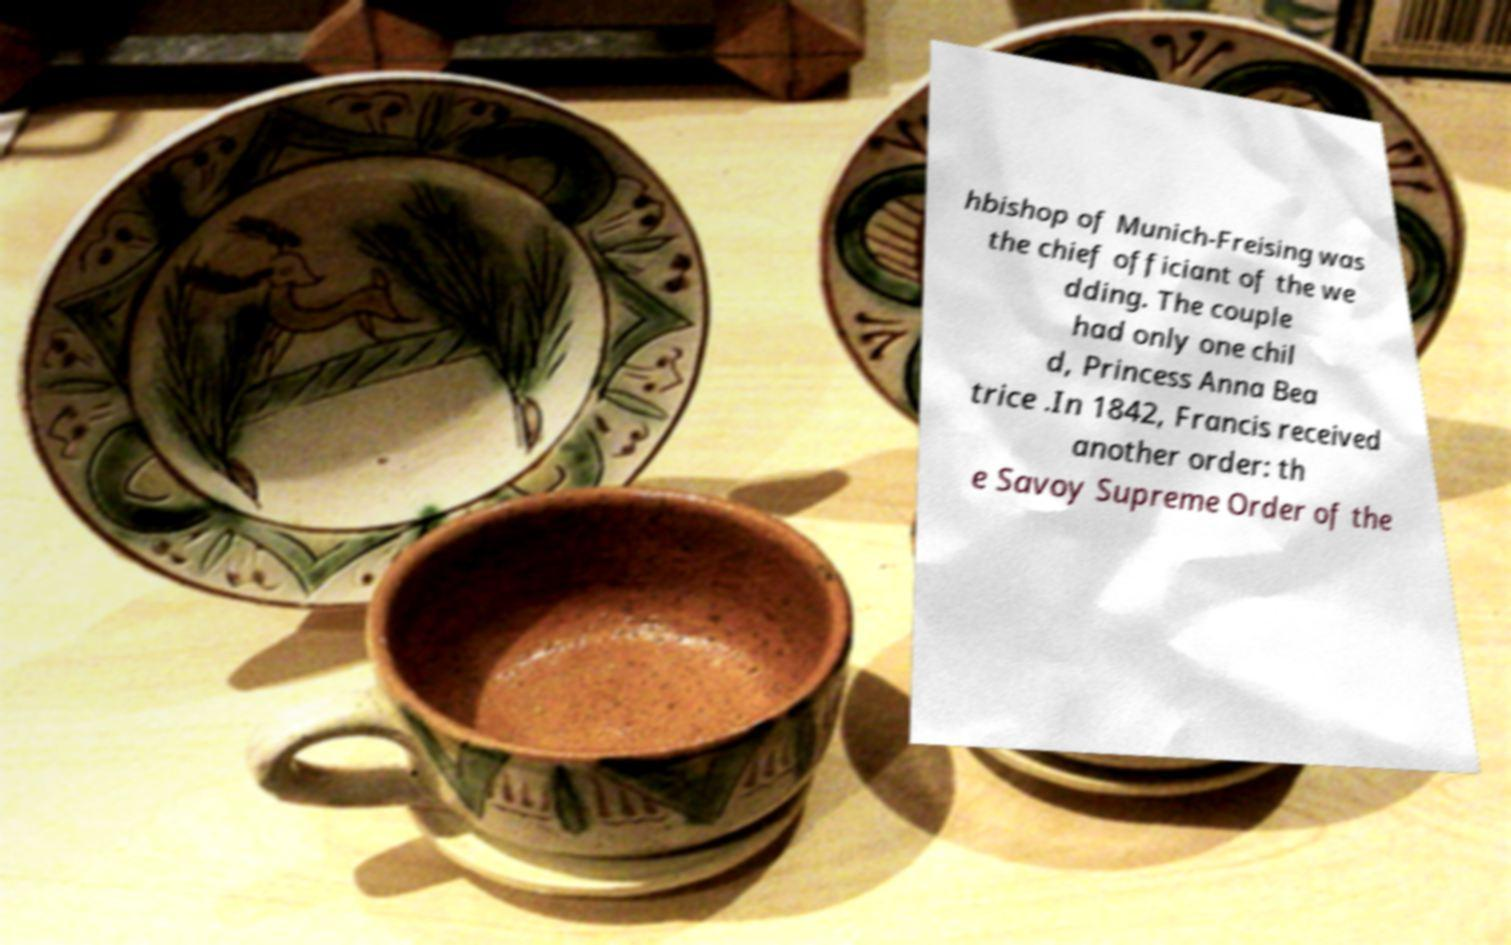Could you extract and type out the text from this image? hbishop of Munich-Freising was the chief officiant of the we dding. The couple had only one chil d, Princess Anna Bea trice .In 1842, Francis received another order: th e Savoy Supreme Order of the 